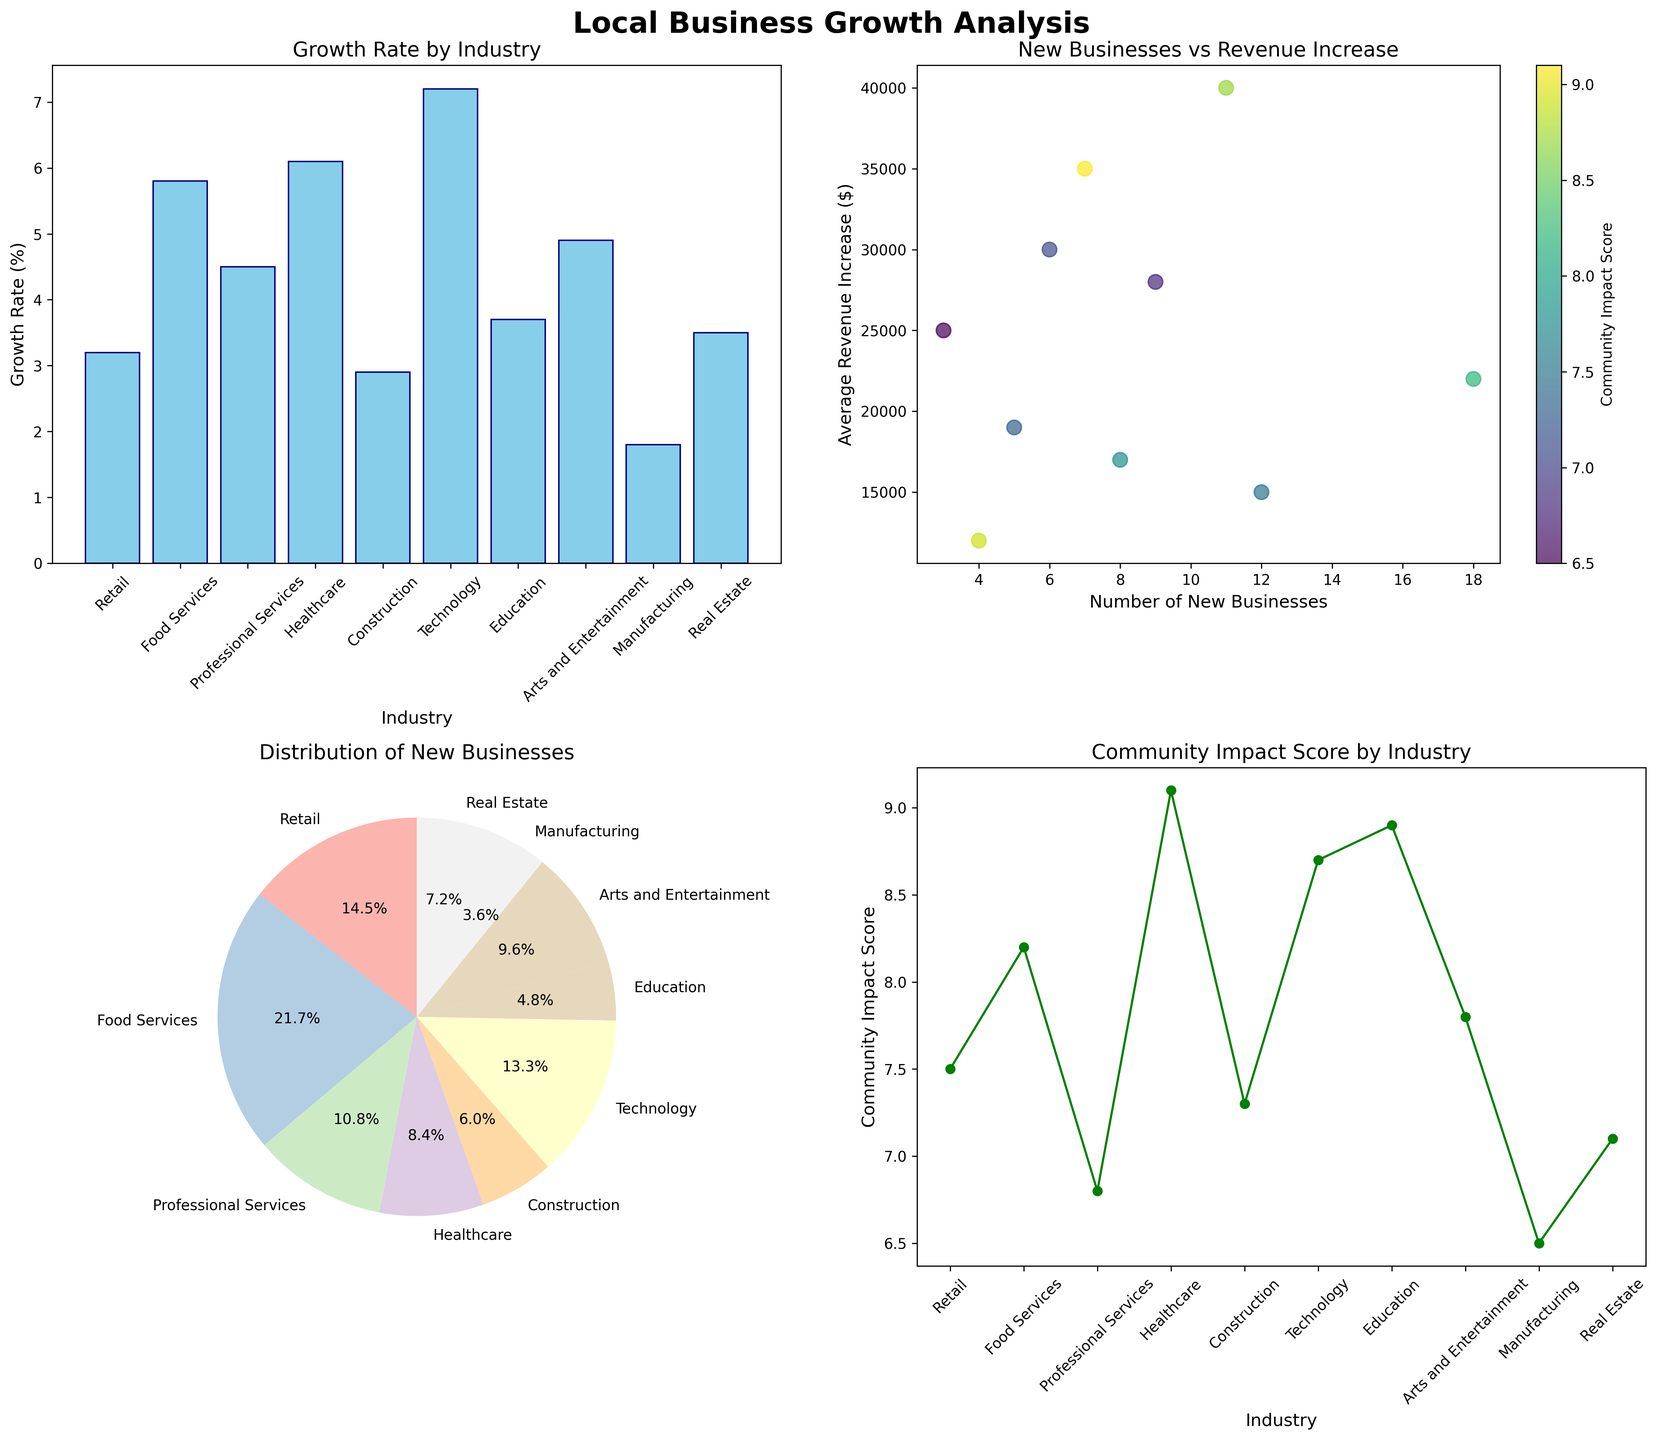What's the growth rate of the Technology industry? The bar plot titled "Growth Rate by Industry" shows the growth rates of different industries. Look for the Technology industry bar, which shows a growth rate of 7.2%.
Answer: 7.2% What is the title of the bar chart? The title of the bar chart is displayed at the top above the bar chart. The title of the bar chart is "Growth Rate by Industry".
Answer: Growth Rate by Industry Which industry has the highest average revenue increase? The scatter plot titled "New Businesses vs Revenue Increase" shows the average revenue increase for different industries. The highest point on the y-axis corresponds to the Technology industry, indicating the highest average revenue increase.
Answer: Technology What is the total number of new businesses in Healthcare and Manufacturing combined? The pie chart titled "Distribution of New Businesses" shows the number of new businesses for each industry. Healthcare has 7 new businesses, and Manufacturing has 3. Adding them results in 7 + 3 = 10.
Answer: 10 Which industry has the lowest community impact score? The line plot titled "Community Impact Score by Industry" shows the community impact scores for each industry. The lowest point on this line plot corresponds to Manufacturing, with a score of 6.5.
Answer: Manufacturing Comparing Retail and Food Services, which industry has a higher growth rate? In the bar plot "Growth Rate by Industry", compare the bars for Retail and Food Services. Retail has a growth rate of 3.2%, while Food Services is higher at 5.8%.
Answer: Food Services How many industries have an average revenue increase greater than $30,000? In the scatter plot "New Businesses vs Revenue Increase", each point represents an industry. The y-axis represents average revenue increase. Points above $30,000 include Healthcare, Technology, and Real Estate, making the total 3 industries.
Answer: 3 What percentage of new businesses are in Professional Services? The pie chart "Distribution of New Businesses" displays the share of new businesses in each industry as percentages. Look for the section labeled Professional Services, which shows 9 new businesses out of the total. The percentage displayed for Professional Services is 15.3%.
Answer: 15.3% Which industry has a higher community impact score, Education or Construction? Refer to the line plot "Community Impact Score by Industry". Compare the community impact scores for Education, which is 8.9, and Construction, which is 7.3. Education has a higher score.
Answer: Education 